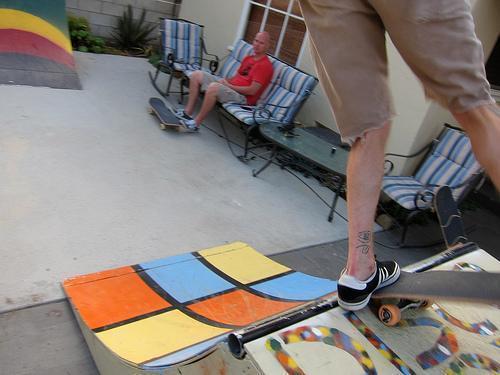How many boys are skateboarding?
Give a very brief answer. 1. 